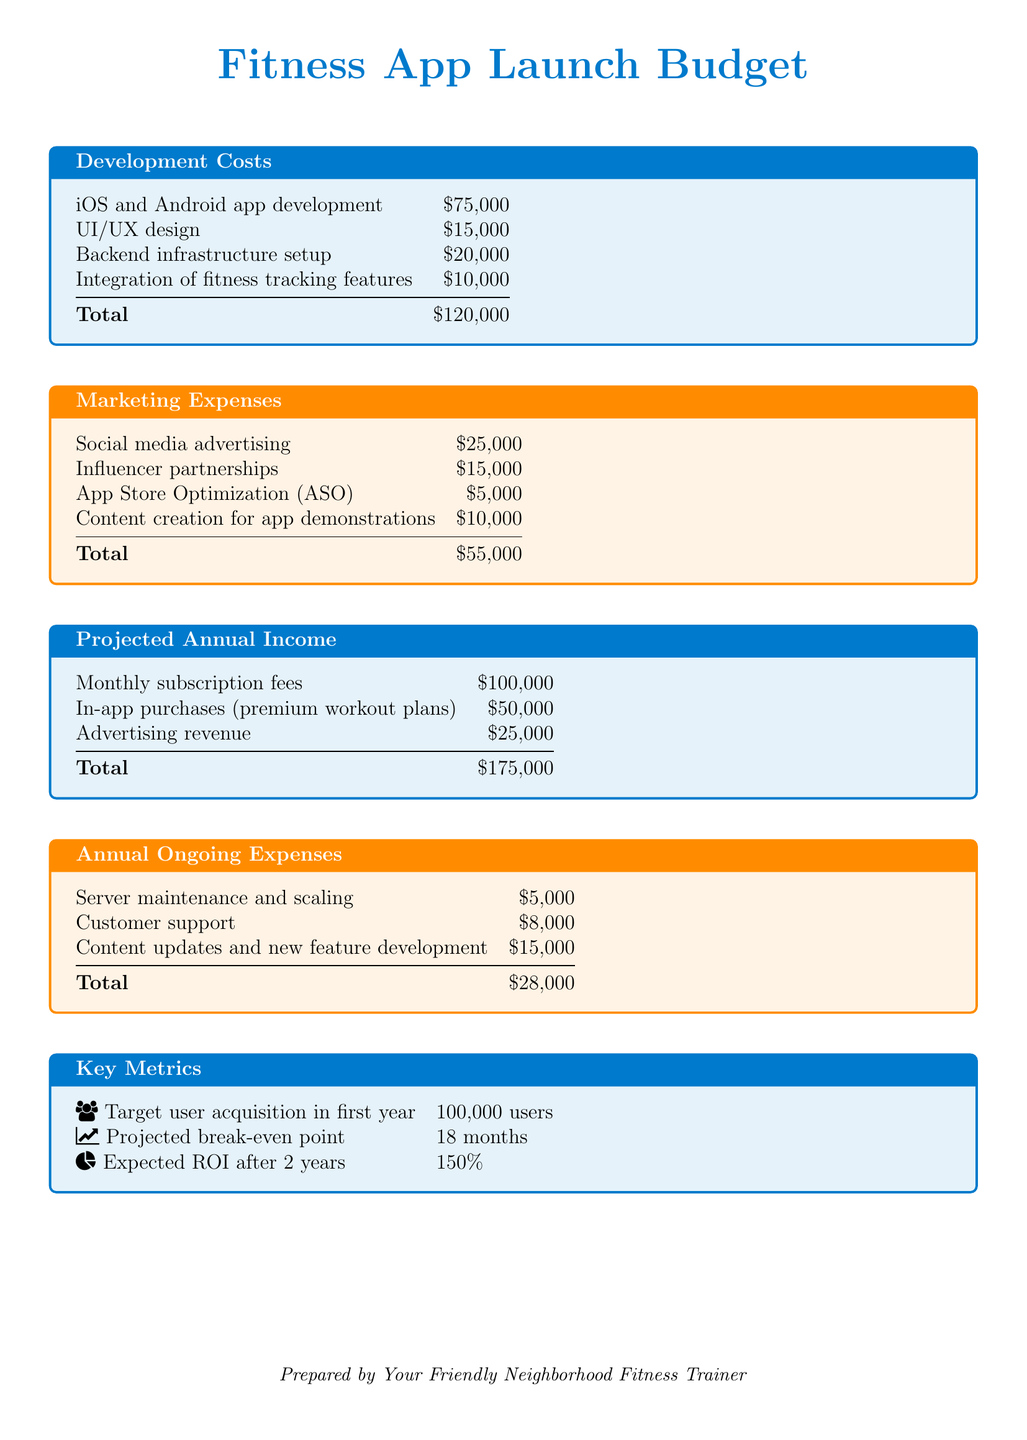what is the total development cost? The total development cost is calculated by summing the individual development cost items listed in the document.
Answer: $120,000 what are the marketing expenses for influencer partnerships? The document specifies the amount allocated for influencer partnerships under marketing expenses.
Answer: $15,000 what is the projected annual income from in-app purchases? The projected annual income from in-app purchases is provided as a distinct revenue source in the income section.
Answer: $50,000 what is the total for annual ongoing expenses? Total ongoing expenses are derived by adding all ongoing expense items mentioned in the document.
Answer: $28,000 how many users are targeted for acquisition in the first year? The document explicitly states the target user acquisition goal for the fitness app in the key metrics section.
Answer: 100,000 users what is the projected break-even point? The break-even point is described as the time required to recover the initial investment, provided in the key metrics.
Answer: 18 months what is the amount allocated for App Store Optimization (ASO)? This amount is included in the marketing expenses section, specifying the total set for ASO.
Answer: $5,000 what is the expected return on investment (ROI) after 2 years? The expected ROI is presented as a percentage in the key metrics section of the document.
Answer: 150% what is the amount for UI/UX design? This amount is listed under the development costs as part of the total development expenses.
Answer: $15,000 what are the content updates and new feature development expenses? This item is stated clearly under ongoing expenses, detailing the amount reserved for it.
Answer: $15,000 